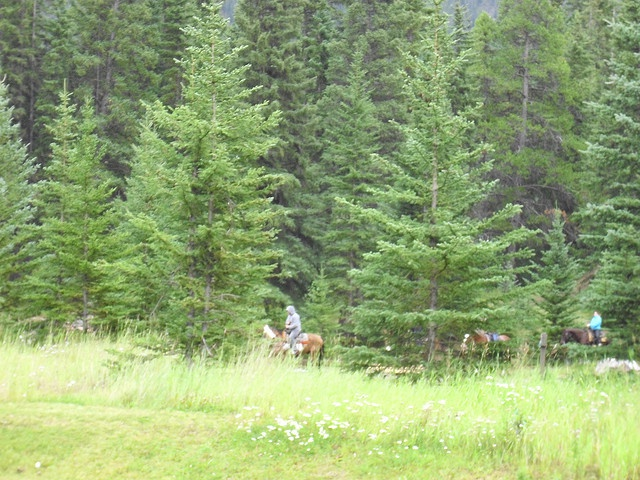Describe the objects in this image and their specific colors. I can see horse in darkgreen and olive tones, horse in darkgreen, white, beige, and tan tones, horse in darkgreen, gray, darkgray, and black tones, people in darkgreen, lightgray, darkgray, and gray tones, and people in darkgreen, gray, lightblue, and darkgray tones in this image. 